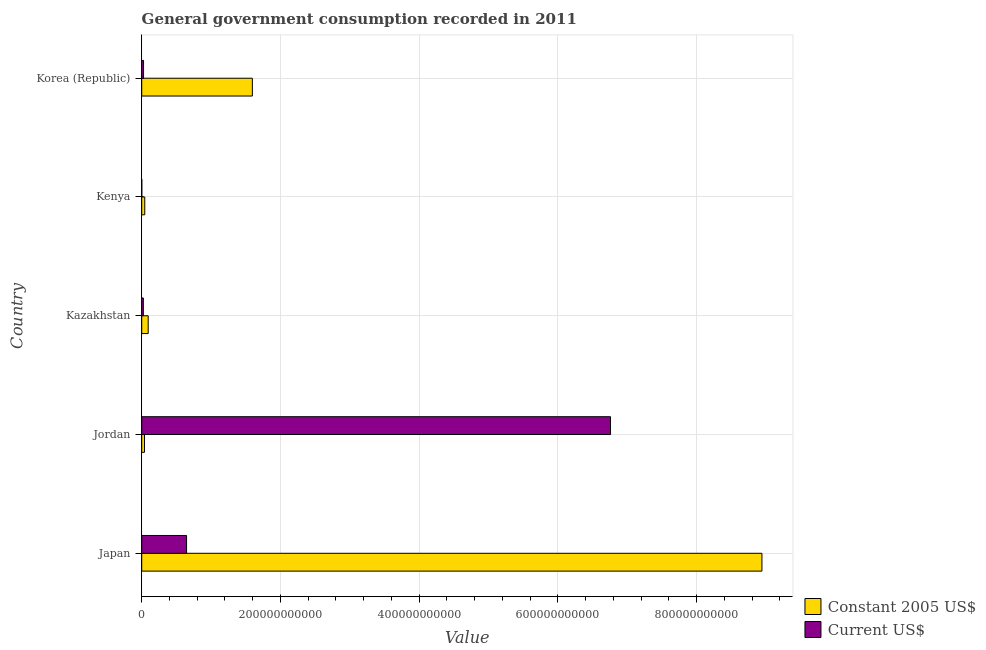How many different coloured bars are there?
Keep it short and to the point. 2. How many bars are there on the 2nd tick from the top?
Give a very brief answer. 2. What is the value consumed in current us$ in Korea (Republic)?
Make the answer very short. 2.63e+09. Across all countries, what is the maximum value consumed in current us$?
Ensure brevity in your answer.  6.76e+11. Across all countries, what is the minimum value consumed in constant 2005 us$?
Provide a succinct answer. 3.98e+09. In which country was the value consumed in current us$ maximum?
Offer a very short reply. Jordan. In which country was the value consumed in current us$ minimum?
Make the answer very short. Kenya. What is the total value consumed in constant 2005 us$ in the graph?
Offer a very short reply. 1.07e+12. What is the difference between the value consumed in current us$ in Japan and that in Korea (Republic)?
Give a very brief answer. 6.20e+1. What is the difference between the value consumed in constant 2005 us$ in Japan and the value consumed in current us$ in Korea (Republic)?
Your answer should be compact. 8.91e+11. What is the average value consumed in current us$ per country?
Your response must be concise. 1.49e+11. What is the difference between the value consumed in constant 2005 us$ and value consumed in current us$ in Kazakhstan?
Provide a succinct answer. 6.98e+09. In how many countries, is the value consumed in current us$ greater than 360000000000 ?
Offer a very short reply. 1. What is the ratio of the value consumed in current us$ in Japan to that in Jordan?
Ensure brevity in your answer.  0.1. Is the value consumed in current us$ in Japan less than that in Kazakhstan?
Your response must be concise. No. Is the difference between the value consumed in current us$ in Jordan and Korea (Republic) greater than the difference between the value consumed in constant 2005 us$ in Jordan and Korea (Republic)?
Your response must be concise. Yes. What is the difference between the highest and the second highest value consumed in constant 2005 us$?
Your response must be concise. 7.35e+11. What is the difference between the highest and the lowest value consumed in current us$?
Make the answer very short. 6.76e+11. What does the 1st bar from the top in Kenya represents?
Ensure brevity in your answer.  Current US$. What does the 1st bar from the bottom in Korea (Republic) represents?
Offer a very short reply. Constant 2005 US$. How many bars are there?
Make the answer very short. 10. Are all the bars in the graph horizontal?
Offer a terse response. Yes. What is the difference between two consecutive major ticks on the X-axis?
Give a very brief answer. 2.00e+11. Does the graph contain grids?
Keep it short and to the point. Yes. Where does the legend appear in the graph?
Provide a succinct answer. Bottom right. How are the legend labels stacked?
Provide a succinct answer. Vertical. What is the title of the graph?
Provide a succinct answer. General government consumption recorded in 2011. What is the label or title of the X-axis?
Your answer should be very brief. Value. What is the label or title of the Y-axis?
Your response must be concise. Country. What is the Value in Constant 2005 US$ in Japan?
Your answer should be very brief. 8.94e+11. What is the Value in Current US$ in Japan?
Ensure brevity in your answer.  6.46e+1. What is the Value in Constant 2005 US$ in Jordan?
Provide a succinct answer. 3.98e+09. What is the Value in Current US$ in Jordan?
Ensure brevity in your answer.  6.76e+11. What is the Value in Constant 2005 US$ in Kazakhstan?
Provide a succinct answer. 9.31e+09. What is the Value in Current US$ in Kazakhstan?
Your response must be concise. 2.33e+09. What is the Value in Constant 2005 US$ in Kenya?
Provide a short and direct response. 4.39e+09. What is the Value in Current US$ in Kenya?
Ensure brevity in your answer.  9.63e+07. What is the Value of Constant 2005 US$ in Korea (Republic)?
Provide a short and direct response. 1.59e+11. What is the Value of Current US$ in Korea (Republic)?
Provide a short and direct response. 2.63e+09. Across all countries, what is the maximum Value of Constant 2005 US$?
Offer a very short reply. 8.94e+11. Across all countries, what is the maximum Value in Current US$?
Give a very brief answer. 6.76e+11. Across all countries, what is the minimum Value in Constant 2005 US$?
Your response must be concise. 3.98e+09. Across all countries, what is the minimum Value of Current US$?
Make the answer very short. 9.63e+07. What is the total Value of Constant 2005 US$ in the graph?
Offer a terse response. 1.07e+12. What is the total Value in Current US$ in the graph?
Provide a short and direct response. 7.45e+11. What is the difference between the Value of Constant 2005 US$ in Japan and that in Jordan?
Provide a short and direct response. 8.90e+11. What is the difference between the Value in Current US$ in Japan and that in Jordan?
Provide a short and direct response. -6.11e+11. What is the difference between the Value of Constant 2005 US$ in Japan and that in Kazakhstan?
Provide a short and direct response. 8.85e+11. What is the difference between the Value of Current US$ in Japan and that in Kazakhstan?
Your answer should be very brief. 6.23e+1. What is the difference between the Value of Constant 2005 US$ in Japan and that in Kenya?
Make the answer very short. 8.90e+11. What is the difference between the Value of Current US$ in Japan and that in Kenya?
Your answer should be very brief. 6.45e+1. What is the difference between the Value of Constant 2005 US$ in Japan and that in Korea (Republic)?
Ensure brevity in your answer.  7.35e+11. What is the difference between the Value in Current US$ in Japan and that in Korea (Republic)?
Make the answer very short. 6.20e+1. What is the difference between the Value in Constant 2005 US$ in Jordan and that in Kazakhstan?
Offer a very short reply. -5.33e+09. What is the difference between the Value in Current US$ in Jordan and that in Kazakhstan?
Provide a succinct answer. 6.73e+11. What is the difference between the Value in Constant 2005 US$ in Jordan and that in Kenya?
Provide a succinct answer. -4.10e+08. What is the difference between the Value of Current US$ in Jordan and that in Kenya?
Offer a terse response. 6.76e+11. What is the difference between the Value in Constant 2005 US$ in Jordan and that in Korea (Republic)?
Provide a succinct answer. -1.56e+11. What is the difference between the Value in Current US$ in Jordan and that in Korea (Republic)?
Offer a very short reply. 6.73e+11. What is the difference between the Value in Constant 2005 US$ in Kazakhstan and that in Kenya?
Provide a succinct answer. 4.92e+09. What is the difference between the Value in Current US$ in Kazakhstan and that in Kenya?
Offer a terse response. 2.23e+09. What is the difference between the Value in Constant 2005 US$ in Kazakhstan and that in Korea (Republic)?
Keep it short and to the point. -1.50e+11. What is the difference between the Value of Current US$ in Kazakhstan and that in Korea (Republic)?
Provide a short and direct response. -3.00e+08. What is the difference between the Value in Constant 2005 US$ in Kenya and that in Korea (Republic)?
Your answer should be very brief. -1.55e+11. What is the difference between the Value in Current US$ in Kenya and that in Korea (Republic)?
Ensure brevity in your answer.  -2.53e+09. What is the difference between the Value in Constant 2005 US$ in Japan and the Value in Current US$ in Jordan?
Provide a short and direct response. 2.18e+11. What is the difference between the Value of Constant 2005 US$ in Japan and the Value of Current US$ in Kazakhstan?
Keep it short and to the point. 8.92e+11. What is the difference between the Value of Constant 2005 US$ in Japan and the Value of Current US$ in Kenya?
Your answer should be very brief. 8.94e+11. What is the difference between the Value in Constant 2005 US$ in Japan and the Value in Current US$ in Korea (Republic)?
Your answer should be very brief. 8.91e+11. What is the difference between the Value in Constant 2005 US$ in Jordan and the Value in Current US$ in Kazakhstan?
Your response must be concise. 1.65e+09. What is the difference between the Value of Constant 2005 US$ in Jordan and the Value of Current US$ in Kenya?
Give a very brief answer. 3.88e+09. What is the difference between the Value of Constant 2005 US$ in Jordan and the Value of Current US$ in Korea (Republic)?
Your response must be concise. 1.35e+09. What is the difference between the Value of Constant 2005 US$ in Kazakhstan and the Value of Current US$ in Kenya?
Provide a short and direct response. 9.21e+09. What is the difference between the Value of Constant 2005 US$ in Kazakhstan and the Value of Current US$ in Korea (Republic)?
Provide a short and direct response. 6.68e+09. What is the difference between the Value in Constant 2005 US$ in Kenya and the Value in Current US$ in Korea (Republic)?
Your answer should be compact. 1.76e+09. What is the average Value of Constant 2005 US$ per country?
Provide a short and direct response. 2.14e+11. What is the average Value of Current US$ per country?
Your answer should be compact. 1.49e+11. What is the difference between the Value of Constant 2005 US$ and Value of Current US$ in Japan?
Your answer should be compact. 8.29e+11. What is the difference between the Value of Constant 2005 US$ and Value of Current US$ in Jordan?
Offer a terse response. -6.72e+11. What is the difference between the Value of Constant 2005 US$ and Value of Current US$ in Kazakhstan?
Your answer should be compact. 6.98e+09. What is the difference between the Value in Constant 2005 US$ and Value in Current US$ in Kenya?
Offer a very short reply. 4.29e+09. What is the difference between the Value in Constant 2005 US$ and Value in Current US$ in Korea (Republic)?
Your answer should be compact. 1.57e+11. What is the ratio of the Value in Constant 2005 US$ in Japan to that in Jordan?
Your answer should be very brief. 224.75. What is the ratio of the Value of Current US$ in Japan to that in Jordan?
Your answer should be compact. 0.1. What is the ratio of the Value in Constant 2005 US$ in Japan to that in Kazakhstan?
Ensure brevity in your answer.  96.03. What is the ratio of the Value in Current US$ in Japan to that in Kazakhstan?
Offer a terse response. 27.77. What is the ratio of the Value of Constant 2005 US$ in Japan to that in Kenya?
Your answer should be very brief. 203.74. What is the ratio of the Value in Current US$ in Japan to that in Kenya?
Keep it short and to the point. 671.24. What is the ratio of the Value of Constant 2005 US$ in Japan to that in Korea (Republic)?
Offer a very short reply. 5.61. What is the ratio of the Value in Current US$ in Japan to that in Korea (Republic)?
Provide a short and direct response. 24.6. What is the ratio of the Value of Constant 2005 US$ in Jordan to that in Kazakhstan?
Offer a terse response. 0.43. What is the ratio of the Value in Current US$ in Jordan to that in Kazakhstan?
Your answer should be compact. 290.43. What is the ratio of the Value of Constant 2005 US$ in Jordan to that in Kenya?
Make the answer very short. 0.91. What is the ratio of the Value of Current US$ in Jordan to that in Kenya?
Keep it short and to the point. 7018.94. What is the ratio of the Value in Constant 2005 US$ in Jordan to that in Korea (Republic)?
Offer a very short reply. 0.02. What is the ratio of the Value in Current US$ in Jordan to that in Korea (Republic)?
Offer a terse response. 257.23. What is the ratio of the Value in Constant 2005 US$ in Kazakhstan to that in Kenya?
Your answer should be very brief. 2.12. What is the ratio of the Value of Current US$ in Kazakhstan to that in Kenya?
Ensure brevity in your answer.  24.17. What is the ratio of the Value of Constant 2005 US$ in Kazakhstan to that in Korea (Republic)?
Offer a terse response. 0.06. What is the ratio of the Value of Current US$ in Kazakhstan to that in Korea (Republic)?
Your answer should be very brief. 0.89. What is the ratio of the Value in Constant 2005 US$ in Kenya to that in Korea (Republic)?
Make the answer very short. 0.03. What is the ratio of the Value of Current US$ in Kenya to that in Korea (Republic)?
Offer a terse response. 0.04. What is the difference between the highest and the second highest Value in Constant 2005 US$?
Your answer should be compact. 7.35e+11. What is the difference between the highest and the second highest Value of Current US$?
Ensure brevity in your answer.  6.11e+11. What is the difference between the highest and the lowest Value of Constant 2005 US$?
Your response must be concise. 8.90e+11. What is the difference between the highest and the lowest Value in Current US$?
Ensure brevity in your answer.  6.76e+11. 